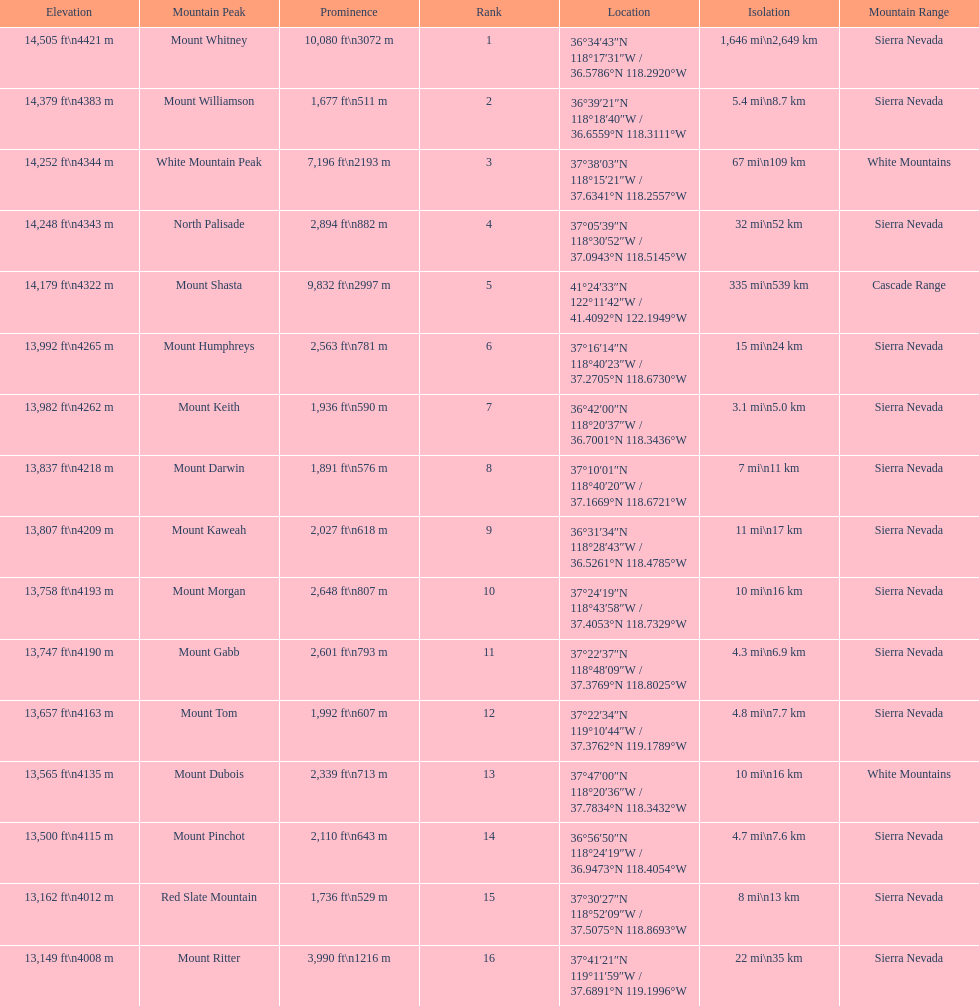What are all of the mountain peaks? Mount Whitney, Mount Williamson, White Mountain Peak, North Palisade, Mount Shasta, Mount Humphreys, Mount Keith, Mount Darwin, Mount Kaweah, Mount Morgan, Mount Gabb, Mount Tom, Mount Dubois, Mount Pinchot, Red Slate Mountain, Mount Ritter. In what ranges are they? Sierra Nevada, Sierra Nevada, White Mountains, Sierra Nevada, Cascade Range, Sierra Nevada, Sierra Nevada, Sierra Nevada, Sierra Nevada, Sierra Nevada, Sierra Nevada, Sierra Nevada, White Mountains, Sierra Nevada, Sierra Nevada, Sierra Nevada. Which peak is in the cascade range? Mount Shasta. 